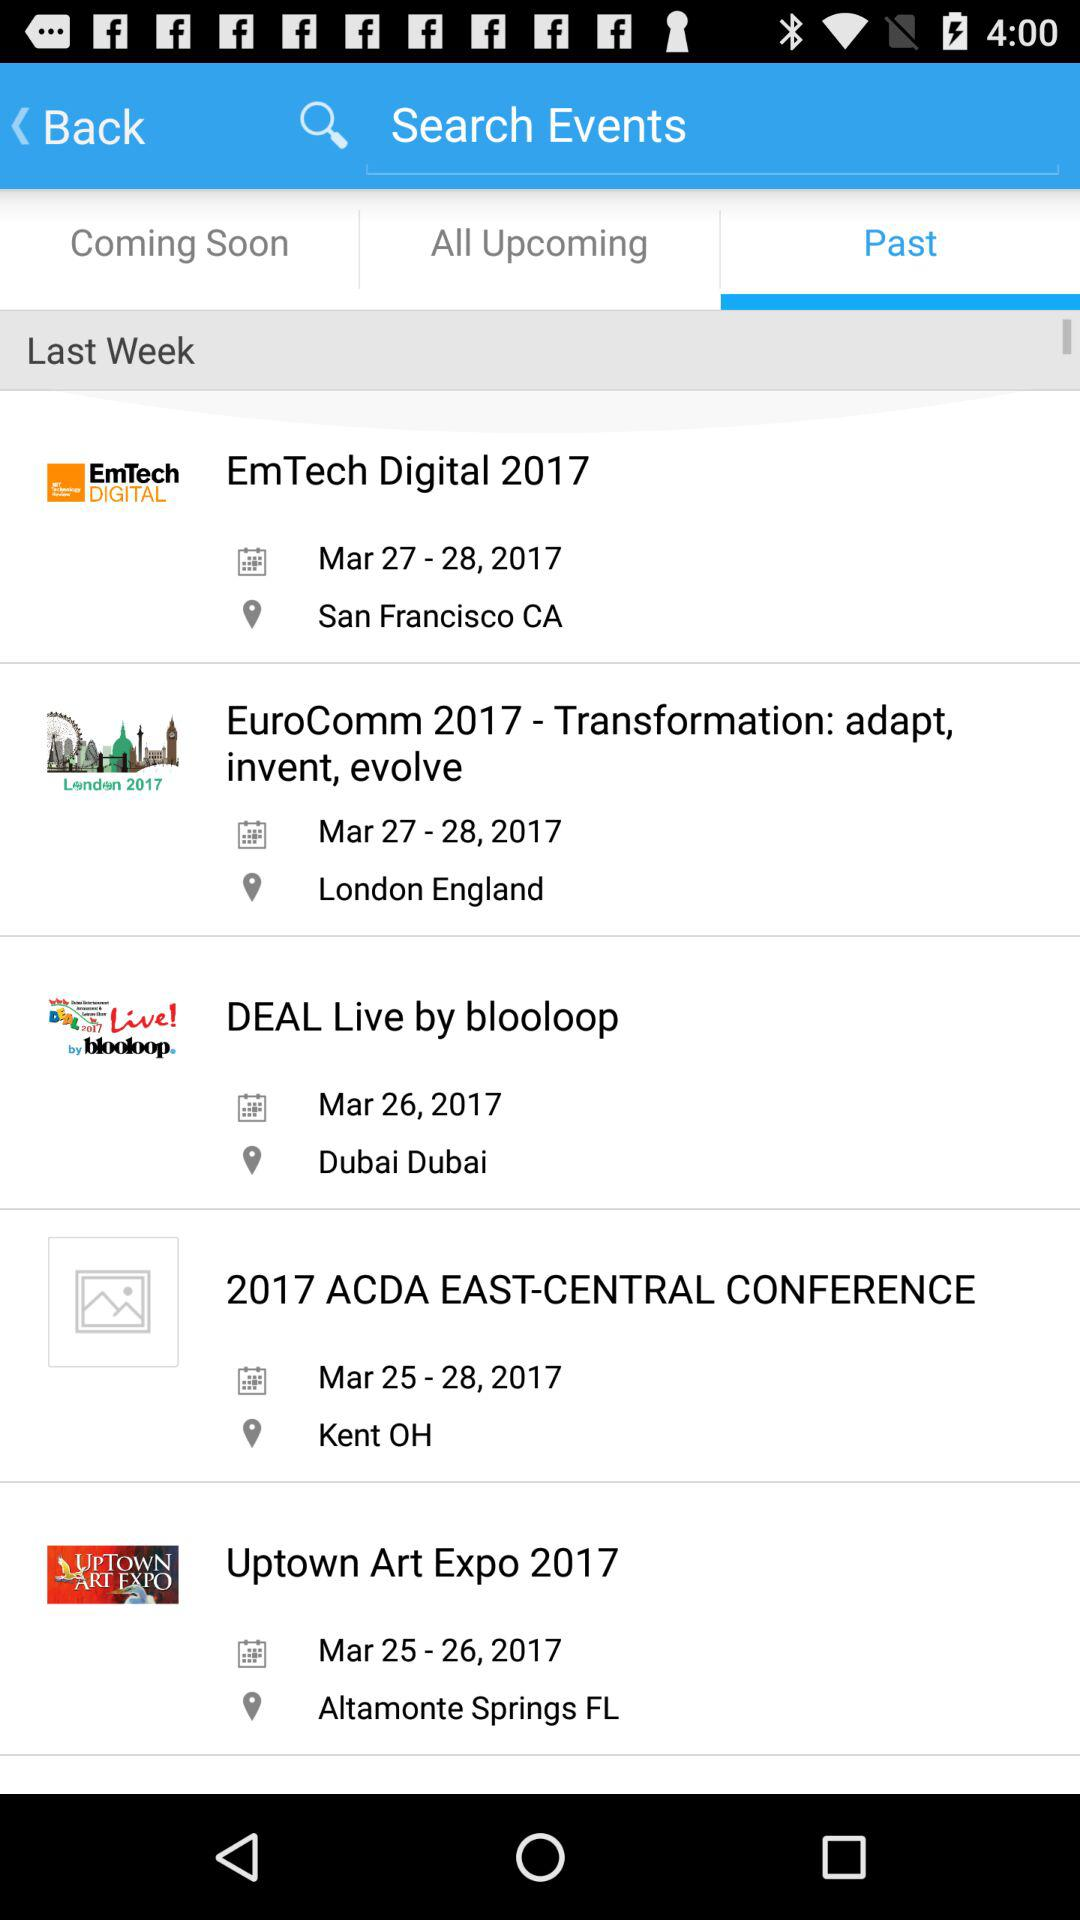What is the location of the "Uptown Art Expo 2017"? The location of the "Uptown Art Expo 2017" is Altamonte Springs, FL. 